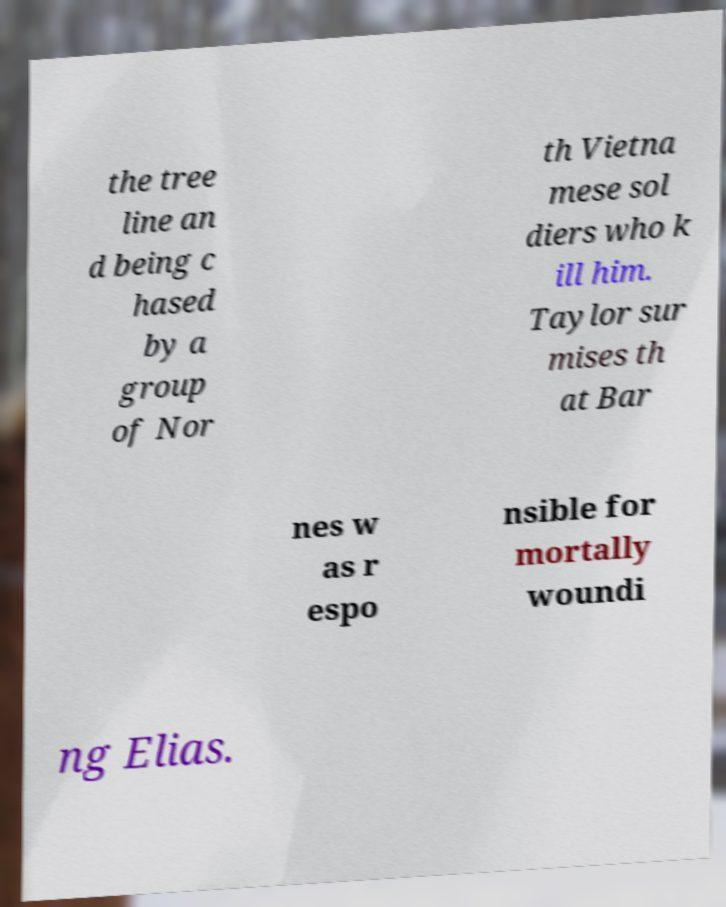Please identify and transcribe the text found in this image. the tree line an d being c hased by a group of Nor th Vietna mese sol diers who k ill him. Taylor sur mises th at Bar nes w as r espo nsible for mortally woundi ng Elias. 